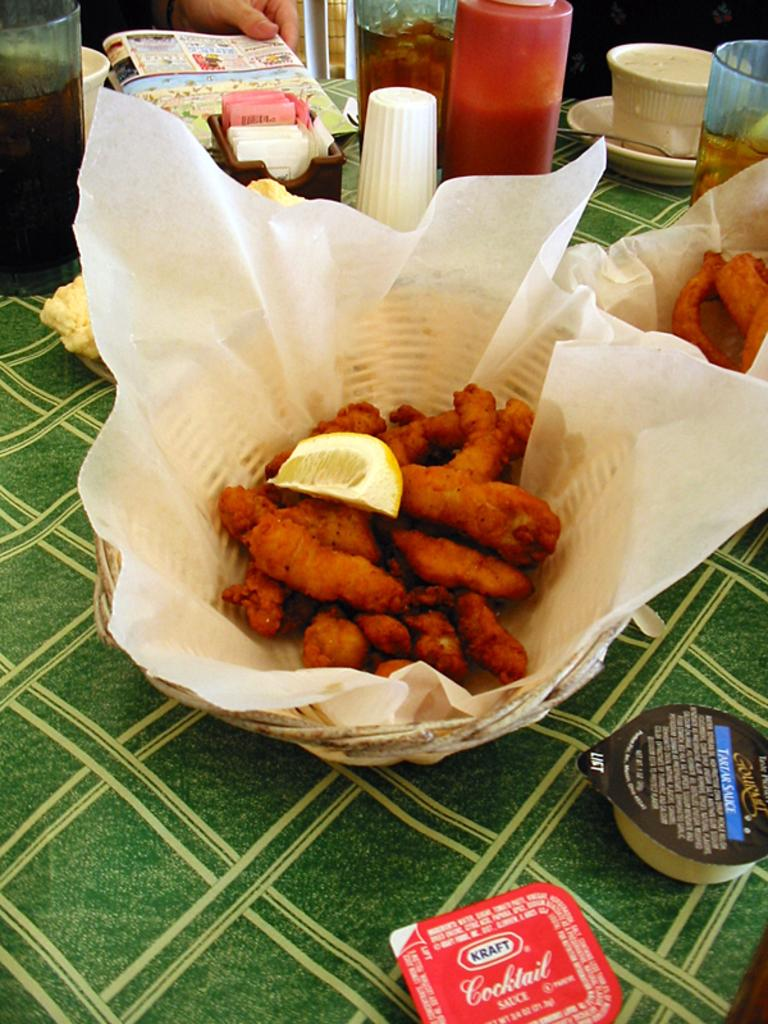<image>
Provide a brief description of the given image. A basket of chicken with a lemon and Kraft cocktail sauce. 